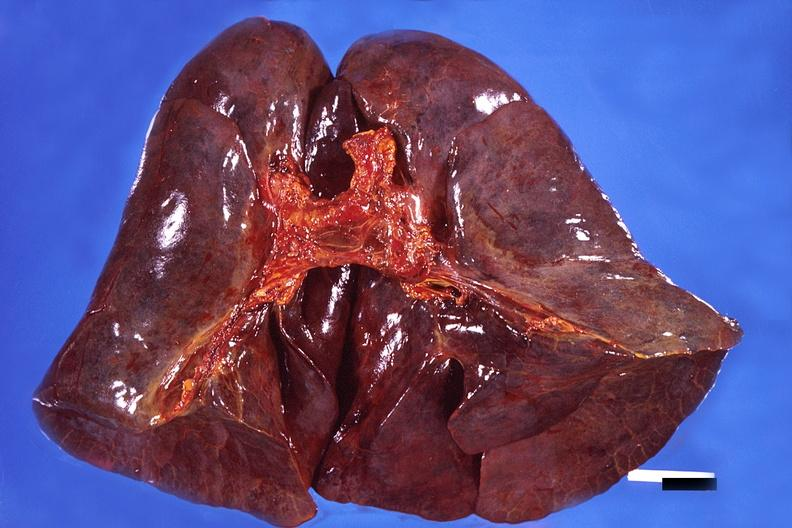does amyloid angiopathy r. endocrine show lung, hemorrhagic bronchopneumonia, wilson 's disease?
Answer the question using a single word or phrase. No 